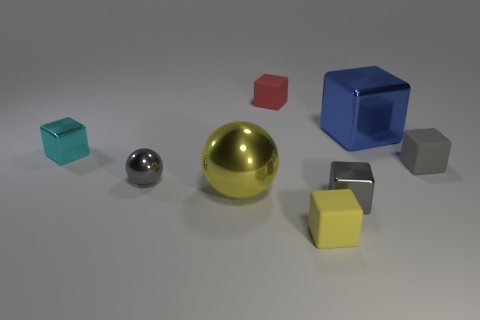Subtract 3 blocks. How many blocks are left? 3 Subtract all large blue cubes. How many cubes are left? 5 Subtract all blue cubes. How many cubes are left? 5 Subtract all purple blocks. Subtract all green spheres. How many blocks are left? 6 Add 2 gray rubber cylinders. How many objects exist? 10 Subtract all cubes. How many objects are left? 2 Add 8 small shiny cubes. How many small shiny cubes exist? 10 Subtract 1 red cubes. How many objects are left? 7 Subtract all metal spheres. Subtract all large spheres. How many objects are left? 5 Add 5 large yellow things. How many large yellow things are left? 6 